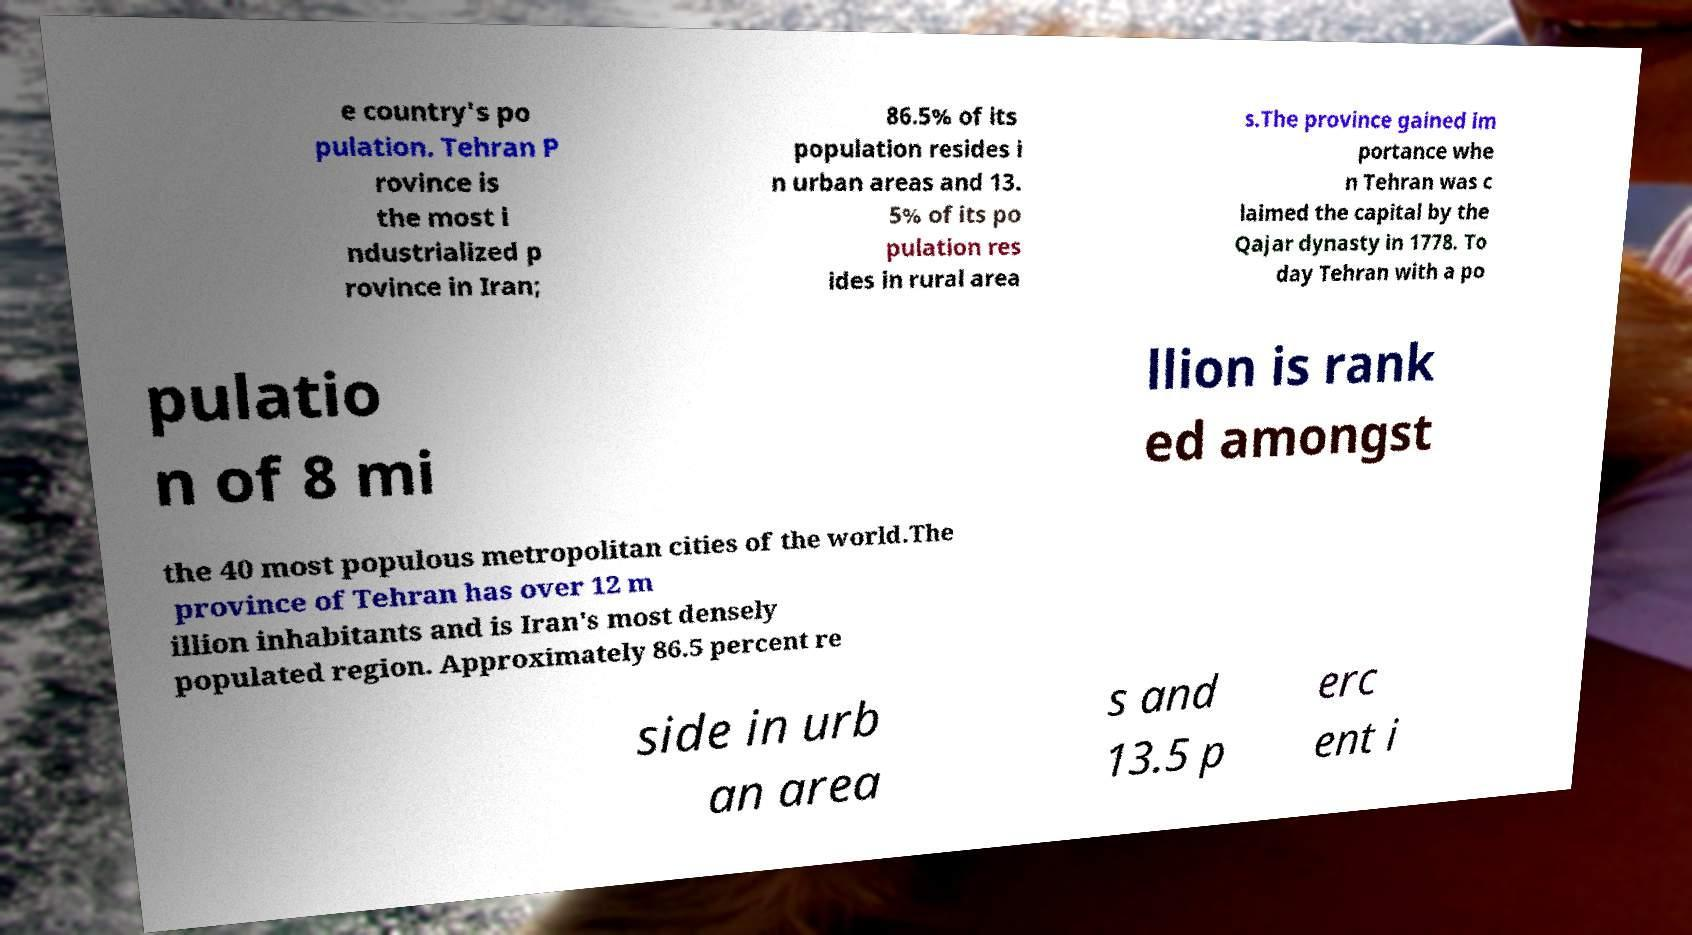What messages or text are displayed in this image? I need them in a readable, typed format. e country's po pulation. Tehran P rovince is the most i ndustrialized p rovince in Iran; 86.5% of its population resides i n urban areas and 13. 5% of its po pulation res ides in rural area s.The province gained im portance whe n Tehran was c laimed the capital by the Qajar dynasty in 1778. To day Tehran with a po pulatio n of 8 mi llion is rank ed amongst the 40 most populous metropolitan cities of the world.The province of Tehran has over 12 m illion inhabitants and is Iran's most densely populated region. Approximately 86.5 percent re side in urb an area s and 13.5 p erc ent i 